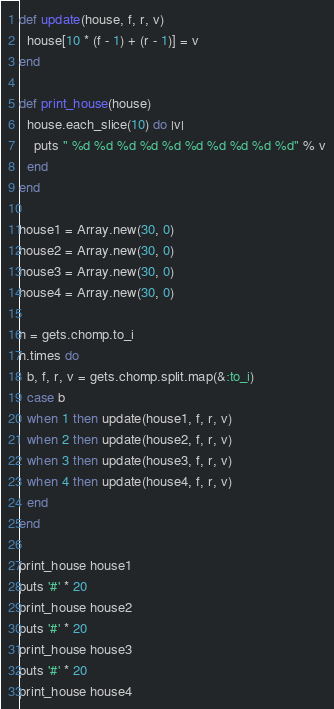<code> <loc_0><loc_0><loc_500><loc_500><_Ruby_>def update(house, f, r, v)
  house[10 * (f - 1) + (r - 1)] = v
end

def print_house(house)
  house.each_slice(10) do |v|
    puts " %d %d %d %d %d %d %d %d %d %d" % v
  end
end

house1 = Array.new(30, 0)
house2 = Array.new(30, 0)
house3 = Array.new(30, 0)
house4 = Array.new(30, 0)

n = gets.chomp.to_i
n.times do
  b, f, r, v = gets.chomp.split.map(&:to_i)
  case b
  when 1 then update(house1, f, r, v)
  when 2 then update(house2, f, r, v)
  when 3 then update(house3, f, r, v)
  when 4 then update(house4, f, r, v)
  end
end

print_house house1
puts '#' * 20
print_house house2
puts '#' * 20
print_house house3
puts '#' * 20
print_house house4</code> 